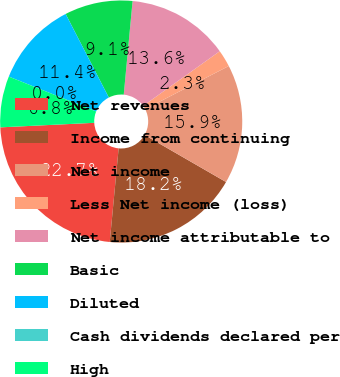Convert chart. <chart><loc_0><loc_0><loc_500><loc_500><pie_chart><fcel>Net revenues<fcel>Income from continuing<fcel>Net income<fcel>Less Net income (loss)<fcel>Net income attributable to<fcel>Basic<fcel>Diluted<fcel>Cash dividends declared per<fcel>High<nl><fcel>22.72%<fcel>18.18%<fcel>15.91%<fcel>2.28%<fcel>13.64%<fcel>9.09%<fcel>11.36%<fcel>0.0%<fcel>6.82%<nl></chart> 